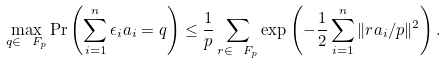<formula> <loc_0><loc_0><loc_500><loc_500>\max _ { q \in \ F _ { p } } \Pr \left ( \sum _ { i = 1 } ^ { n } \epsilon _ { i } a _ { i } = q \right ) \leq \frac { 1 } { p } \sum _ { r \in \ F _ { p } } \exp \left ( - \frac { 1 } { 2 } \sum _ { i = 1 } ^ { n } \| r a _ { i } / p \| ^ { 2 } \right ) .</formula> 